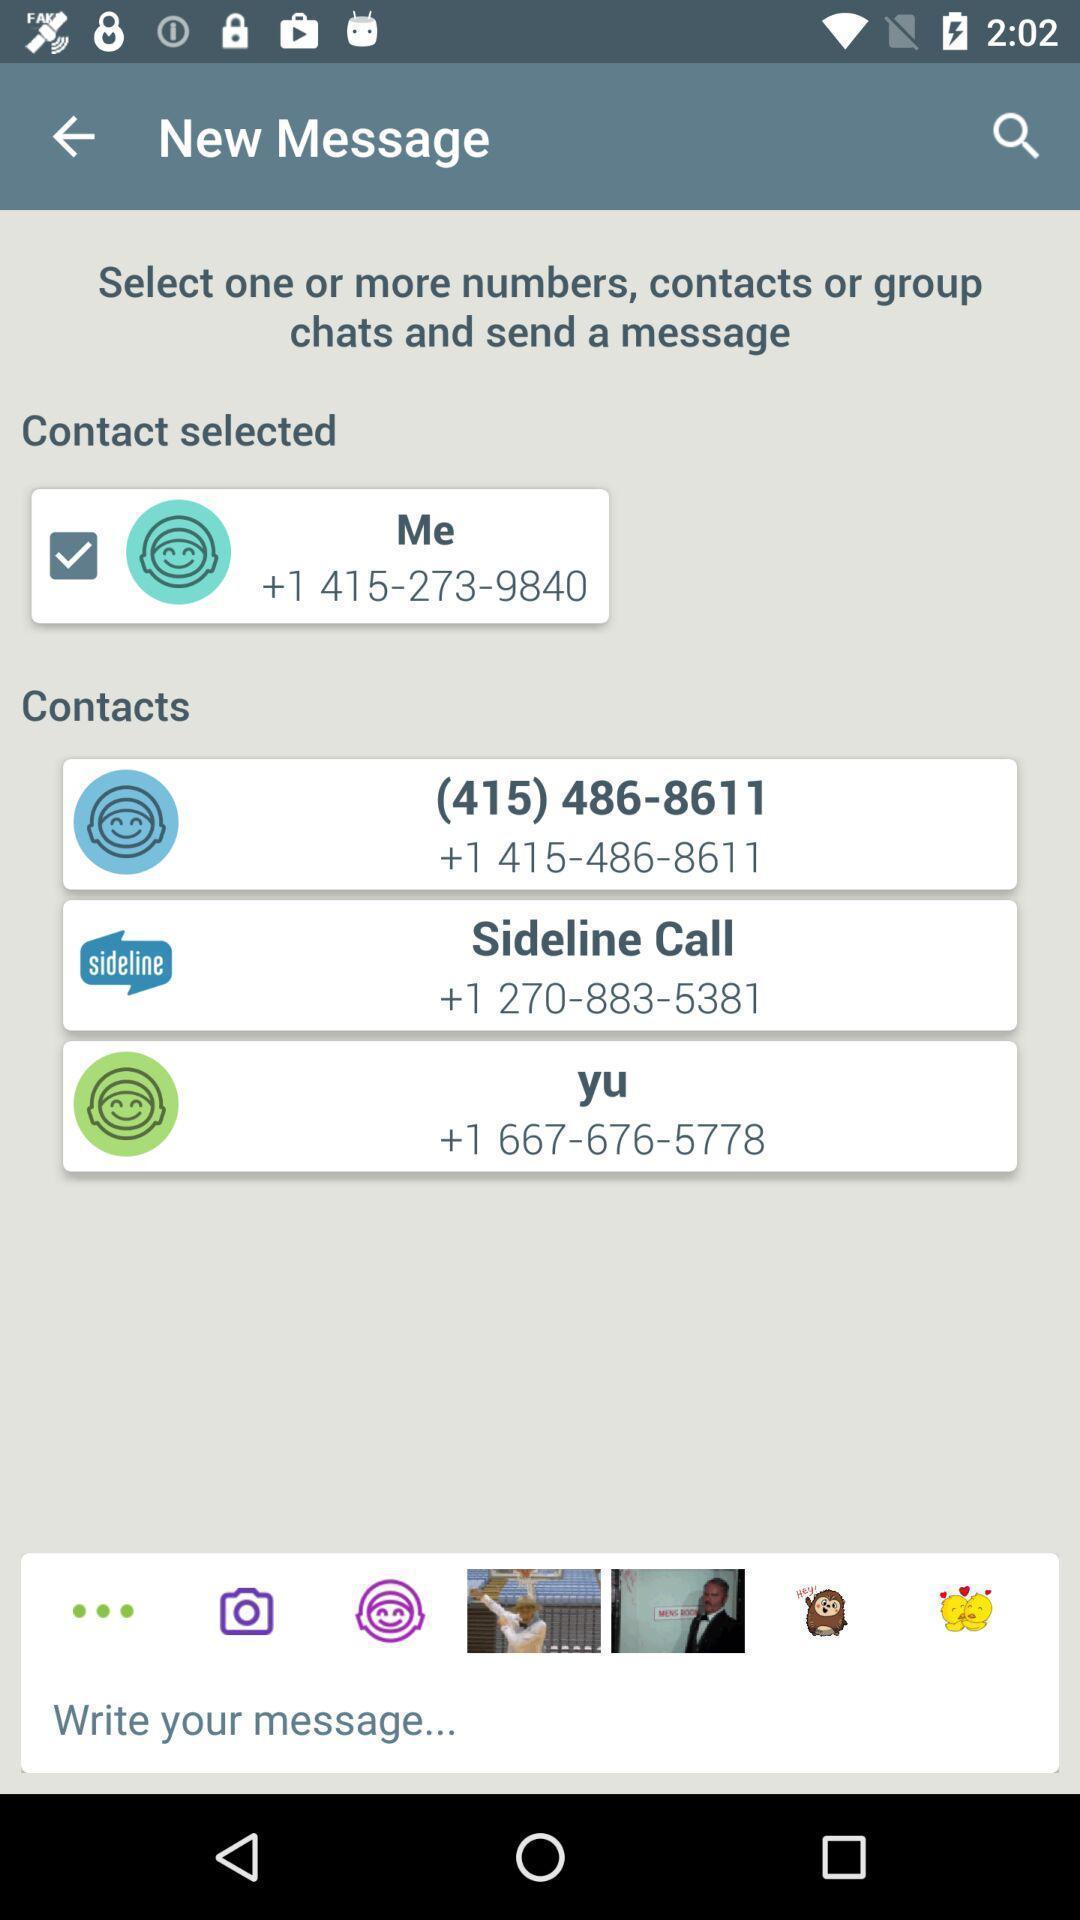Provide a detailed account of this screenshot. Various options to be selected of a communications app. 